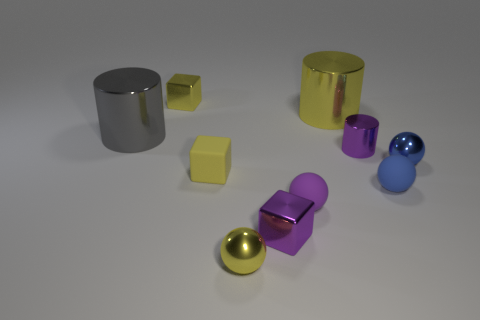There is a large thing that is on the right side of the yellow shiny object in front of the large metal object behind the gray metal object; what is it made of? metal 